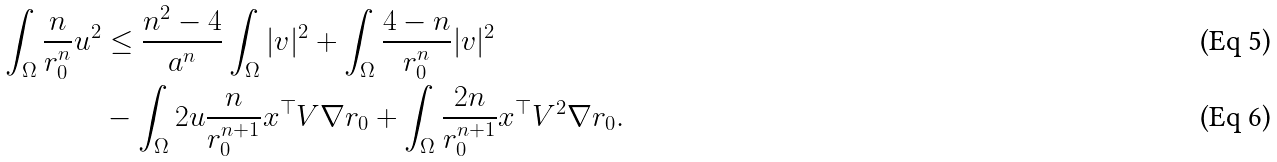Convert formula to latex. <formula><loc_0><loc_0><loc_500><loc_500>\int _ { \Omega } \frac { n } { r _ { 0 } ^ { n } } u ^ { 2 } & \leq \frac { n ^ { 2 } - 4 } { a ^ { n } } \int _ { \Omega } | v | ^ { 2 } + \int _ { \Omega } \frac { 4 - n } { r _ { 0 } ^ { n } } | v | ^ { 2 } \\ & - \int _ { \Omega } 2 u \frac { n } { r _ { 0 } ^ { n + 1 } } x ^ { \top } V \nabla r _ { 0 } + \int _ { \Omega } \frac { 2 n } { r _ { 0 } ^ { n + 1 } } x ^ { \top } V ^ { 2 } \nabla r _ { 0 } .</formula> 